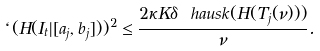<formula> <loc_0><loc_0><loc_500><loc_500>\ell ( H ( I _ { t } | [ a _ { j } , b _ { j } ] ) ) ^ { 2 } \leq \frac { 2 \kappa K \delta \ h a u s k ( H ( T _ { j } ( \nu ) ) ) } { \nu } .</formula> 